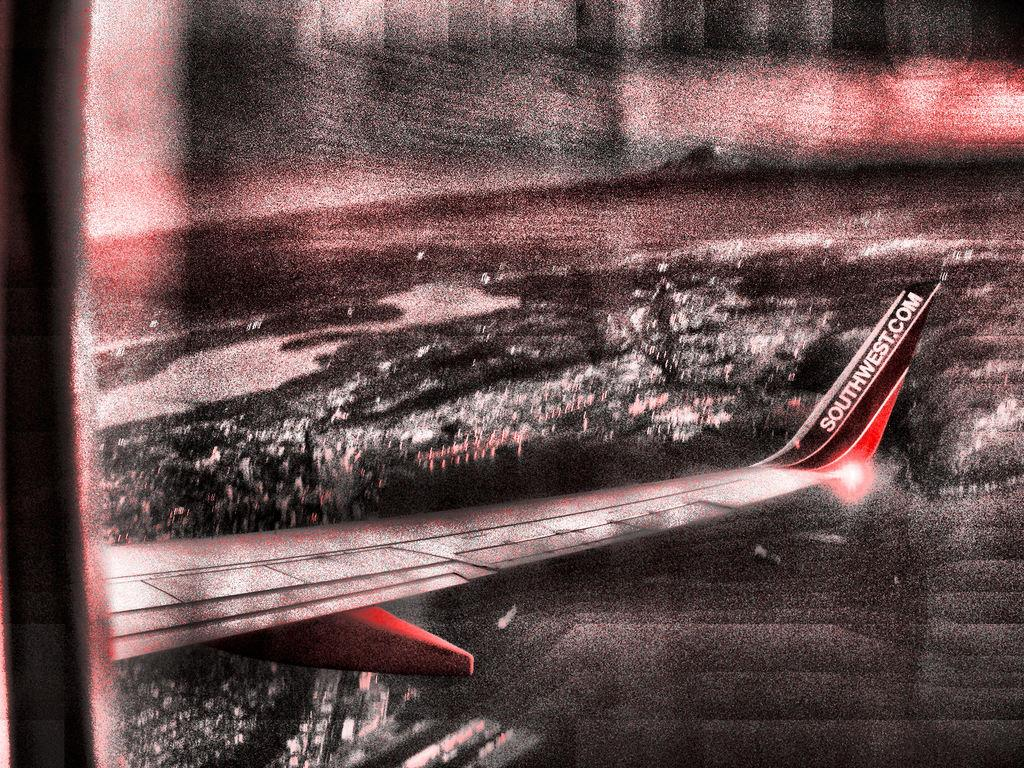<image>
Share a concise interpretation of the image provided. A heavily filtered picture of a Southwest Airlines airplane is seen above a city 